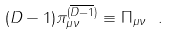Convert formula to latex. <formula><loc_0><loc_0><loc_500><loc_500>( D - 1 ) \pi _ { \mu \nu } ^ { ( \overline { D - 1 } ) } \equiv \Pi _ { \mu \nu } \ .</formula> 